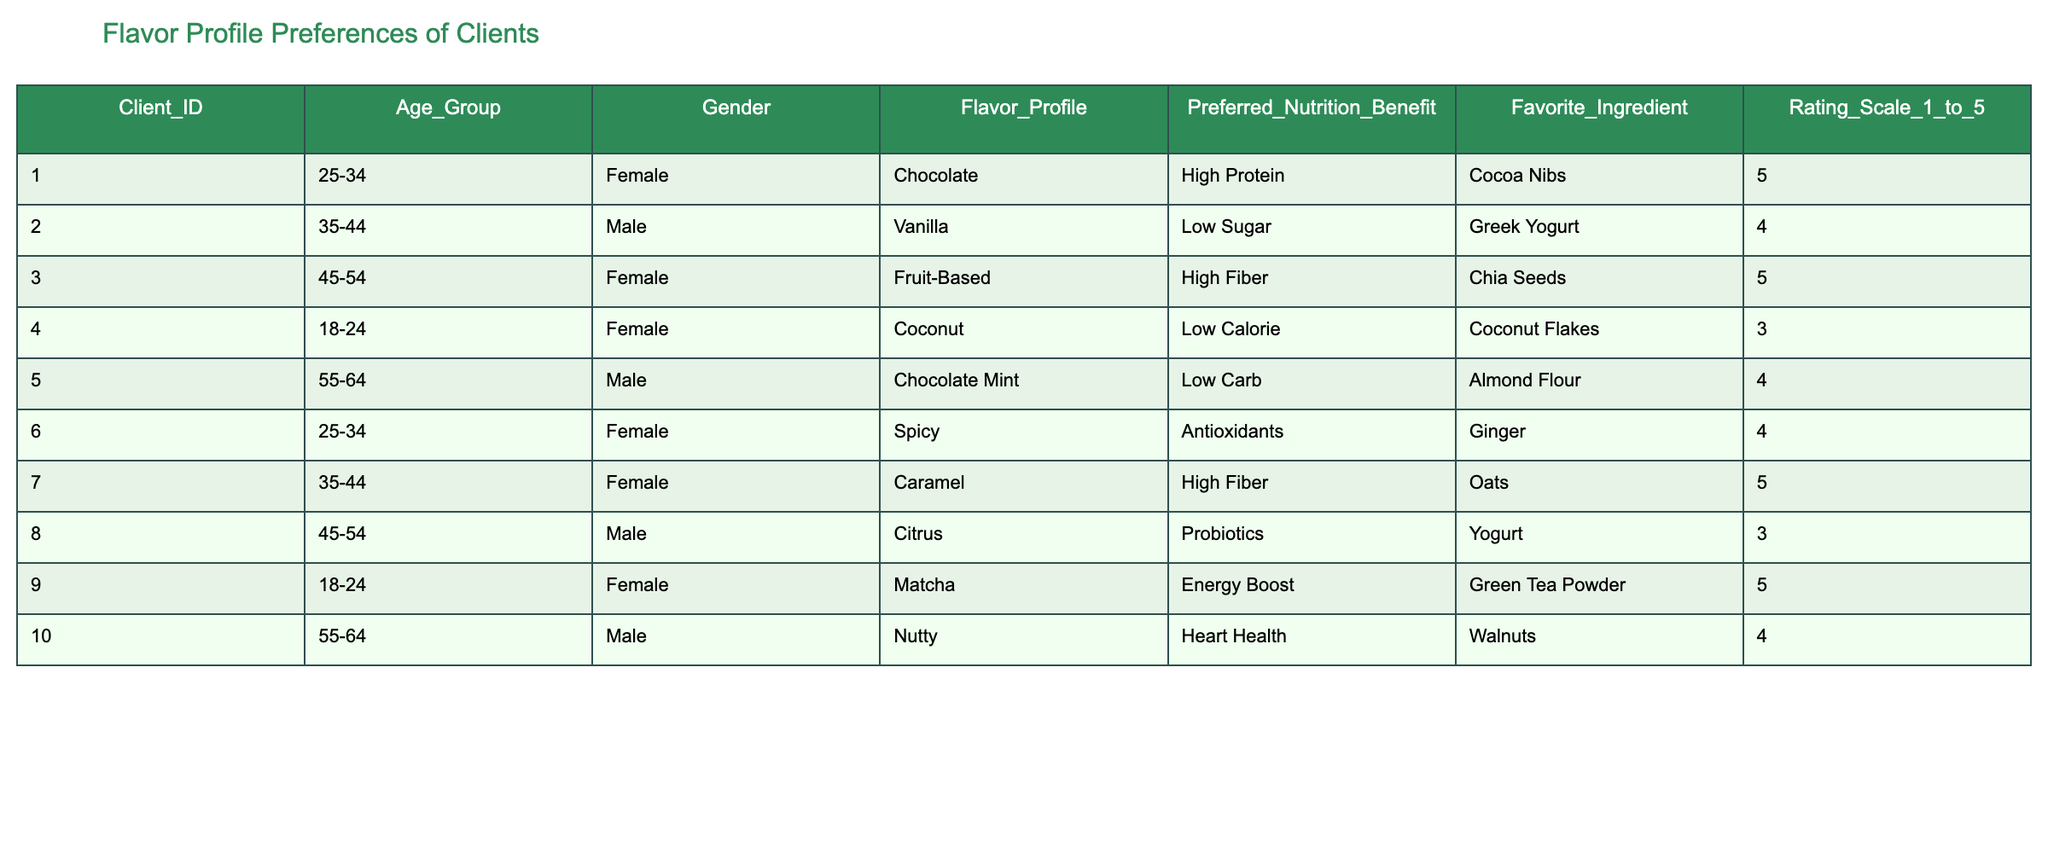What flavor profile has the highest rating? The highest rating in the table is 5, which appears for Chocolate, Fruit-Based, and Matcha flavor profiles. Since multiple flavor profiles have the same highest rating, we can conclude that they are equally preferred.
Answer: Chocolate, Fruit-Based, Matcha Which age group prefers the Coconut flavor profile? Looking at the table, the only age group listed for the Coconut flavor profile is 18-24, with a rating of 3. Therefore, this age group is the only one that prefers this flavor.
Answer: 18-24 Are more male or female clients rating desserts a 5? To find the count of ratings that are 5, we can look through the ratings associated with each gender. Both Female (3 times) and Male (1 time) rated 5. So, Female clients rate desserts a 5 more frequently than Male clients.
Answer: Female What is the average rating for the Spicy flavor profile? The Spicy flavor profile is rated 4 by one client. Since there is only one rating, the average is simply that rating: 4.
Answer: 4 Which flavor profile is associated with the highest nutritional benefit rating? High Protein (Chocolate) and High Fiber (Fruit-Based and Caramel) flavor profiles have ratings of 5. Therefore, both High Protein and High Fiber are associated with the highest nutritional benefits according to the table.
Answer: High Protein, High Fiber 